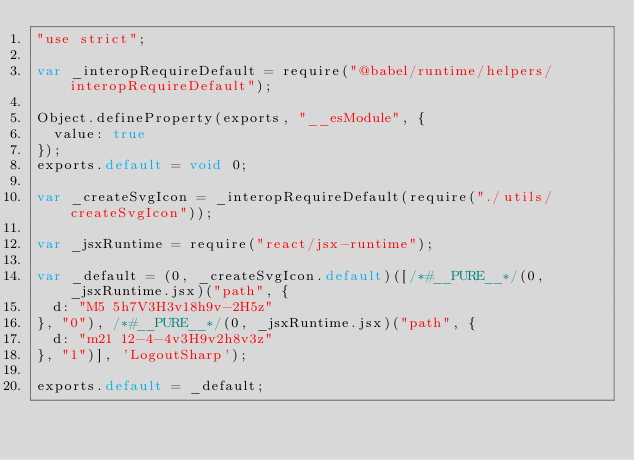Convert code to text. <code><loc_0><loc_0><loc_500><loc_500><_JavaScript_>"use strict";

var _interopRequireDefault = require("@babel/runtime/helpers/interopRequireDefault");

Object.defineProperty(exports, "__esModule", {
  value: true
});
exports.default = void 0;

var _createSvgIcon = _interopRequireDefault(require("./utils/createSvgIcon"));

var _jsxRuntime = require("react/jsx-runtime");

var _default = (0, _createSvgIcon.default)([/*#__PURE__*/(0, _jsxRuntime.jsx)("path", {
  d: "M5 5h7V3H3v18h9v-2H5z"
}, "0"), /*#__PURE__*/(0, _jsxRuntime.jsx)("path", {
  d: "m21 12-4-4v3H9v2h8v3z"
}, "1")], 'LogoutSharp');

exports.default = _default;</code> 